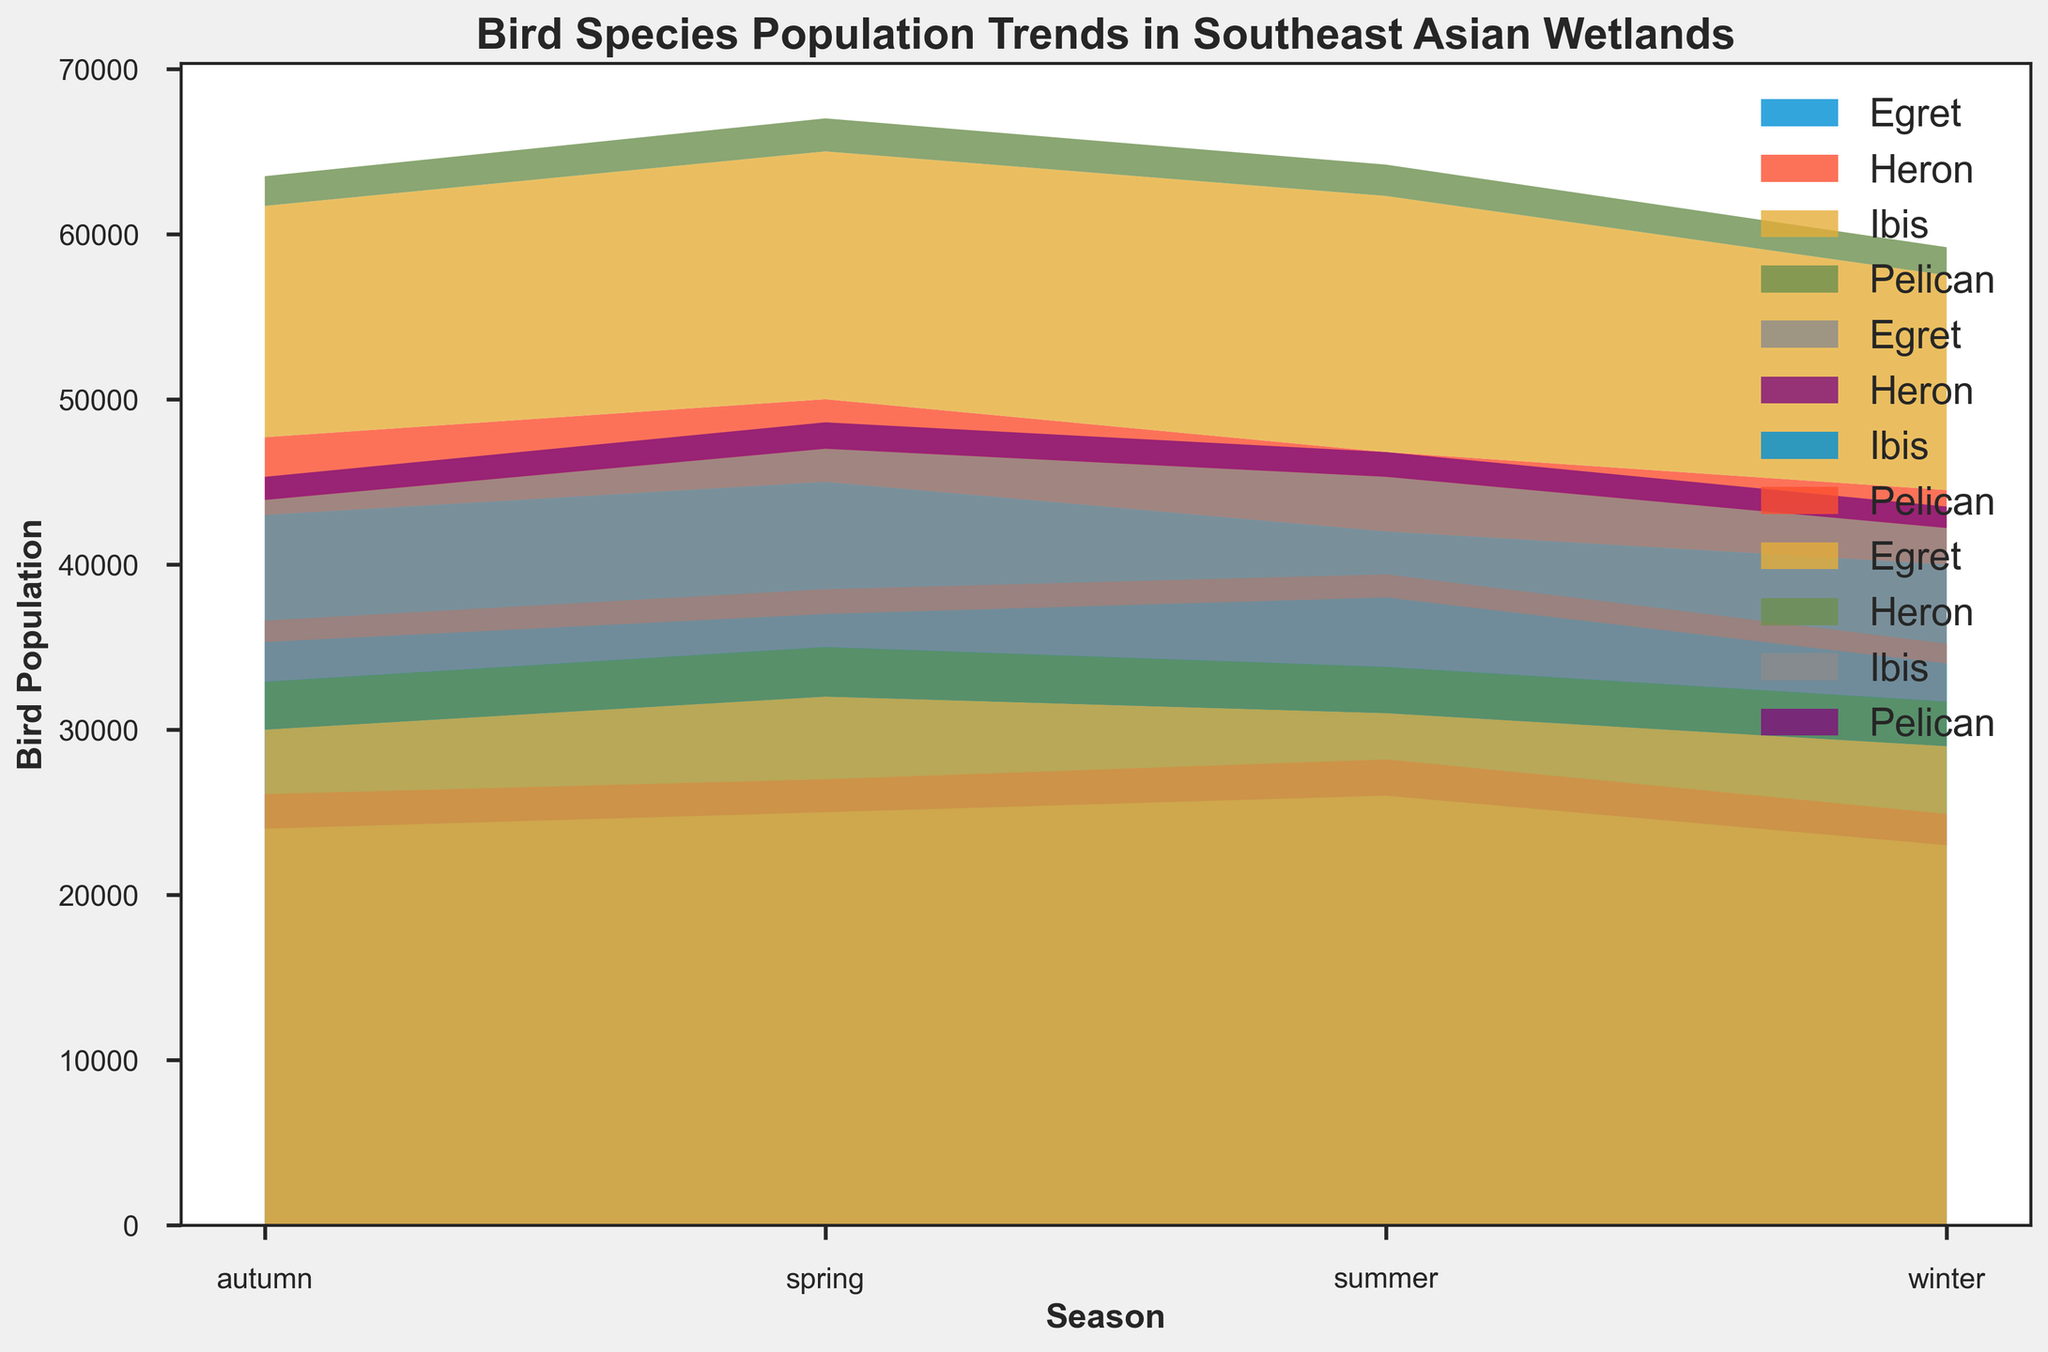Which country has the highest Egret population in winter? To find this, locate the winter segment on the x-axis, then check the height of the Egret population segment for each country.
Answer: Thailand Which species shows the greatest population decrease from spring to winter in Malaysia? For Malaysia, compare the changes from spring to winter for each species by noting the difference in area segments between these seasons.
Answer: Egret What is the total bird population in Thailand during spring? Sum up the population segments (Egret, Heron, Ibis, Pelican) in Thailand for spring visible on the y-axis to get the total.
Answer: 67,000 Which season generally shows the highest bird population across all species in Vietnam? Examine the stack heights (total height of all species combined) for each season in Vietnam and identify which season had the highest total stack height.
Answer: Spring How does the population of Herons in winter compare between Thailand and Vietnam? Compare the areas representing Heron populations in winter for both Thailand and Vietnam by checking their respective heights in the stack.
Answer: Thailand > Vietnam Which species is most populous in Vietnam across all seasons? Compare the area sizes of each species in all seasons in Vietnam to identify the largest area.
Answer: Egret Which species in Thailand has the least population in summer? Look at the summer segment for Thailand and check the heights of population areas for each species to find the smallest one.
Answer: Pelican What is the average population of Ibises in Malaysia throughout the year? Get the population values of Ibises for each season in Malaysia, sum them up, and then divide by the number of seasons (4).
Answer: 9,775 Which season has the lowest combined bird population in Thailand? Observe the total height of the stacks for each season in Thailand and identify the one with the lowest combined height.
Answer: Winter 